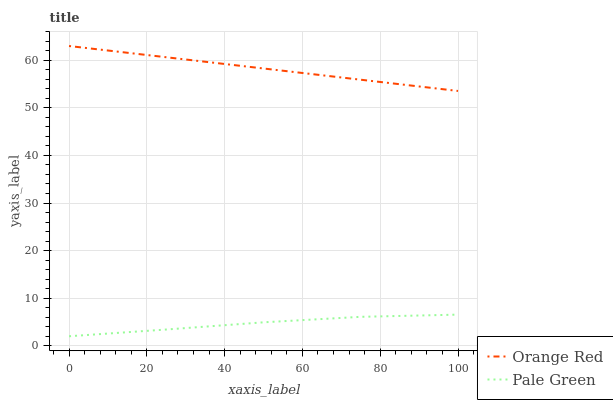Does Pale Green have the minimum area under the curve?
Answer yes or no. Yes. Does Orange Red have the maximum area under the curve?
Answer yes or no. Yes. Does Orange Red have the minimum area under the curve?
Answer yes or no. No. Is Orange Red the smoothest?
Answer yes or no. Yes. Is Pale Green the roughest?
Answer yes or no. Yes. Is Orange Red the roughest?
Answer yes or no. No. Does Pale Green have the lowest value?
Answer yes or no. Yes. Does Orange Red have the lowest value?
Answer yes or no. No. Does Orange Red have the highest value?
Answer yes or no. Yes. Is Pale Green less than Orange Red?
Answer yes or no. Yes. Is Orange Red greater than Pale Green?
Answer yes or no. Yes. Does Pale Green intersect Orange Red?
Answer yes or no. No. 